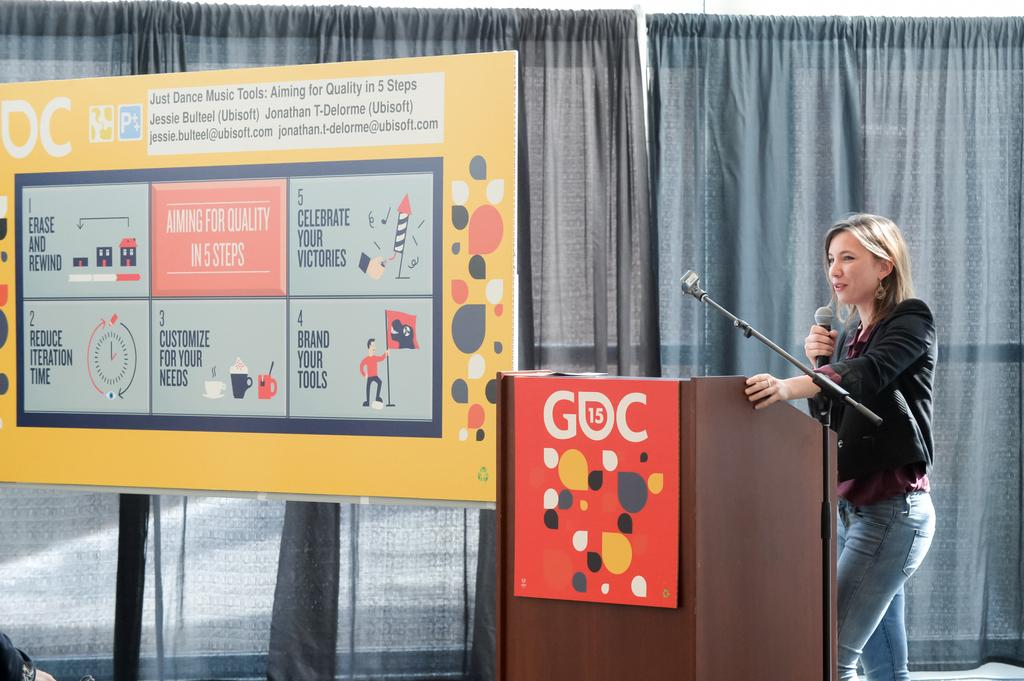What is the woman in the image doing near the podium? The woman is standing near a podium and talking. What is the woman holding in the image? The woman is holding a microphone. What can be seen in the background of the image? There are curtains in the background of the image. What else is present in the image besides the woman and the podium? There are banners in the image. Where is the pet located in the image? There is no pet present in the image. What type of bedroom furniture can be seen in the image? There is no bedroom furniture present in the image. 